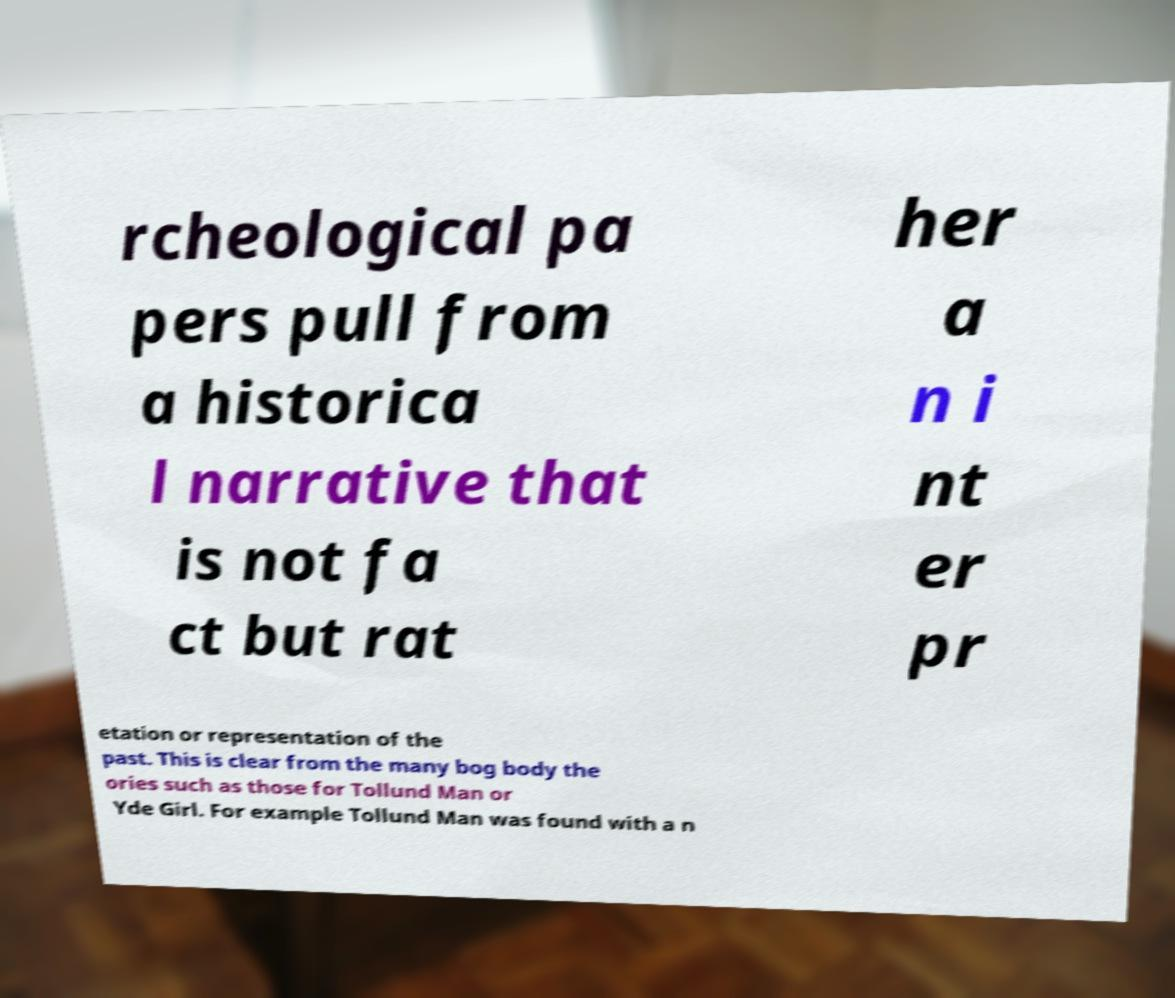I need the written content from this picture converted into text. Can you do that? rcheological pa pers pull from a historica l narrative that is not fa ct but rat her a n i nt er pr etation or representation of the past. This is clear from the many bog body the ories such as those for Tollund Man or Yde Girl. For example Tollund Man was found with a n 